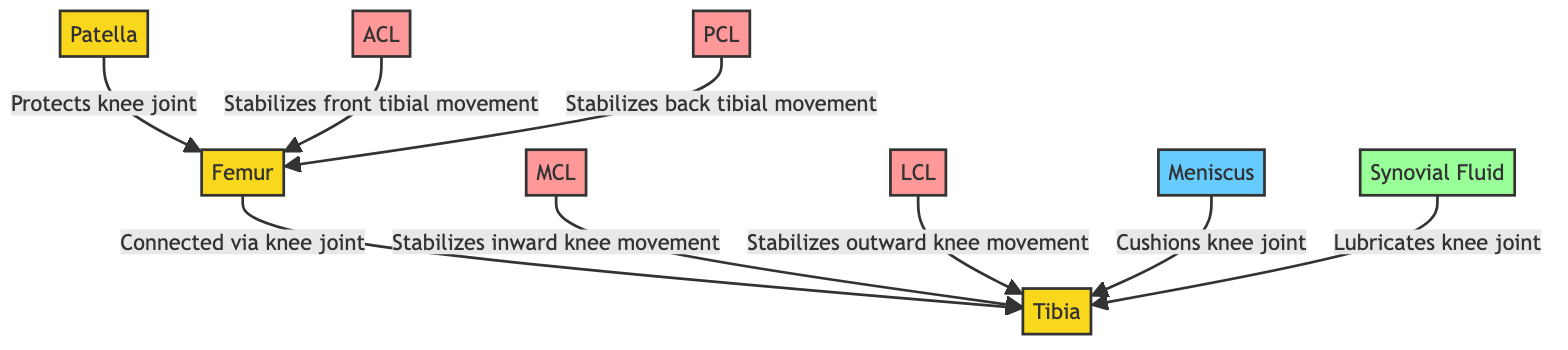What are the three main bones in the human knee joint? The diagram shows the femur, tibia, and patella as the main bones that compose the human knee joint.
Answer: femur, tibia, patella Which ligament stabilizes inward knee movement? According to the diagram, the MCL (Medial Collateral Ligament) is the one that stabilizes inward knee movement.
Answer: MCL How many ligaments are shown in the diagram? The diagram displays a total of four ligaments: ACL, PCL, MCL, and LCL. To determine this, I counted the ligaments represented in the diagram.
Answer: 4 What is the function of the synovial fluid? The diagram indicates that synovial fluid lubricates the knee joint, which helps reduce friction during movement.
Answer: Lubricates knee joint Which component cushions the knee joint? The meniscus, as shown in the diagram, is specifically designated to cushion the knee joint during movement and impact.
Answer: Meniscus What connects the femur and tibia? The diagram shows that the femur and tibia are connected via the knee joint, which facilitates movement between these two bones.
Answer: Knee joint Which ligament stabilizes back tibial movement? The PCL (Posterior Cruciate Ligament) in the diagram stabilizes back tibial movement. This relationship is directly indicated between PCL and the femur.
Answer: PCL What structure protects the knee joint? The patella is mentioned in the diagram as the structure that protects the knee joint, serving as a shield for this area during movement.
Answer: Patella How does the meniscus relate to tibia in the diagram? The meniscus is depicted as cushioning the knee joint with a direct connection to the tibia, indicating its functional relationship in shock absorption.
Answer: Cushions knee joint 